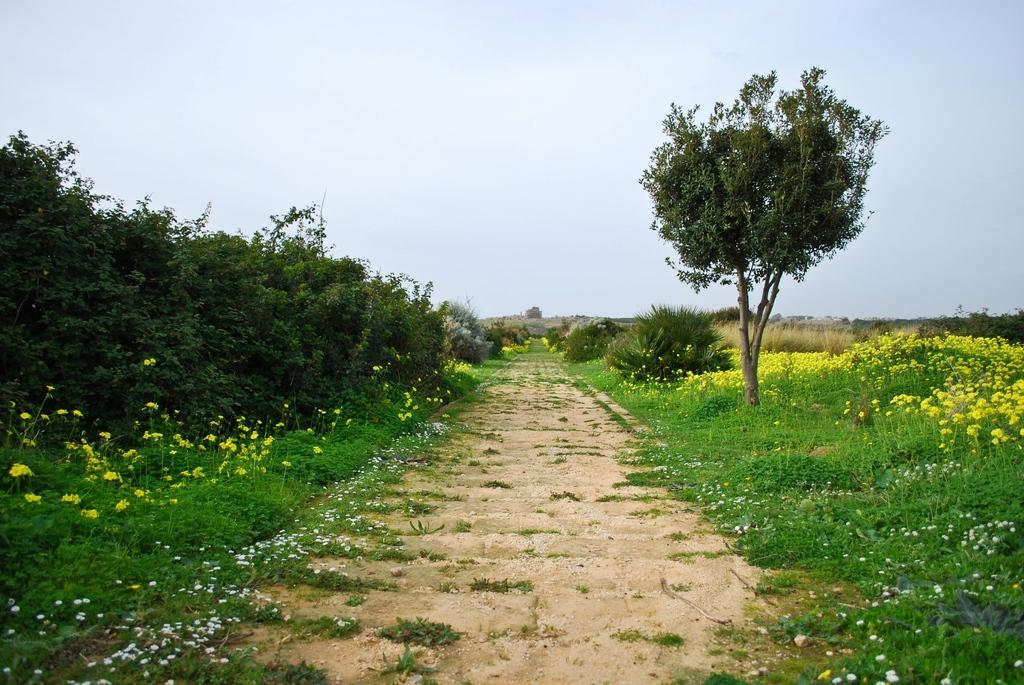What type of vegetation can be seen in the image? There are flowers, grass, plants, and trees in the image. What type of ground surface is present in the image? There are stones in the image. What is visible at the top of the image? The sky is visible at the top of the image. What type of operation is being performed on the son in the image? There is no operation or son present in the image; it features natural elements such as flowers, grass, plants, trees, stones, and the sky. 